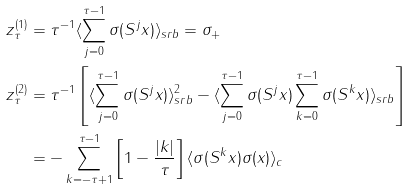Convert formula to latex. <formula><loc_0><loc_0><loc_500><loc_500>z ^ { ( 1 ) } _ { \tau } & = \tau ^ { - 1 } \langle \sum _ { j = 0 } ^ { \tau - 1 } \sigma ( S ^ { j } x ) \rangle _ { s r b } = \sigma _ { + } \\ z ^ { ( 2 ) } _ { \tau } & = \tau ^ { - 1 } \left [ \langle \sum _ { j = 0 } ^ { \tau - 1 } \sigma ( S ^ { j } x ) \rangle _ { s r b } ^ { 2 } - \langle \sum _ { j = 0 } ^ { \tau - 1 } \sigma ( S ^ { j } x ) \sum _ { k = 0 } ^ { \tau - 1 } \sigma ( S ^ { k } x ) \rangle _ { s r b } \right ] \\ & = - \sum _ { k = - \tau + 1 } ^ { \tau - 1 } \left [ 1 - \frac { | k | } { \tau } \right ] \langle \sigma ( S ^ { k } x ) \sigma ( x ) \rangle _ { c }</formula> 